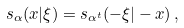Convert formula to latex. <formula><loc_0><loc_0><loc_500><loc_500>s _ { \alpha } ( x | \xi ) = s _ { \alpha ^ { t } } ( - \xi | - x ) \, ,</formula> 